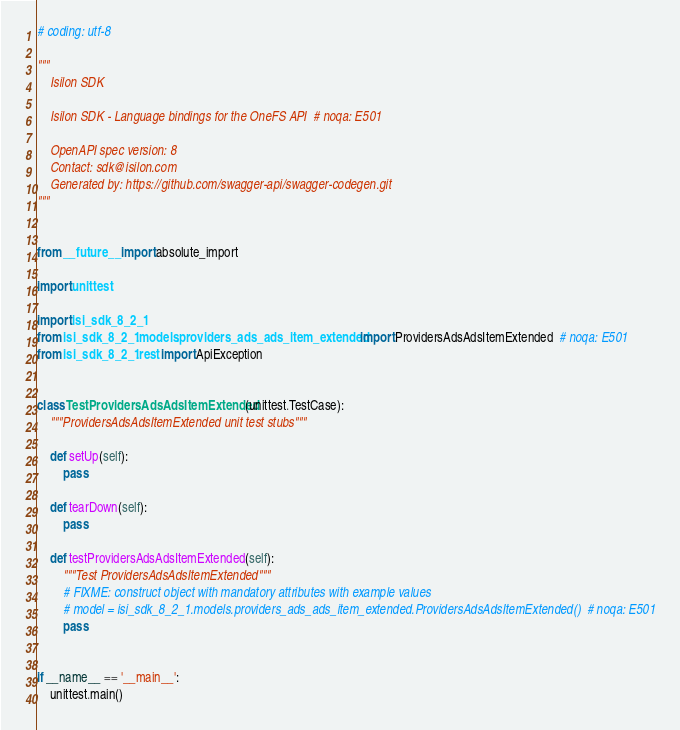<code> <loc_0><loc_0><loc_500><loc_500><_Python_># coding: utf-8

"""
    Isilon SDK

    Isilon SDK - Language bindings for the OneFS API  # noqa: E501

    OpenAPI spec version: 8
    Contact: sdk@isilon.com
    Generated by: https://github.com/swagger-api/swagger-codegen.git
"""


from __future__ import absolute_import

import unittest

import isi_sdk_8_2_1
from isi_sdk_8_2_1.models.providers_ads_ads_item_extended import ProvidersAdsAdsItemExtended  # noqa: E501
from isi_sdk_8_2_1.rest import ApiException


class TestProvidersAdsAdsItemExtended(unittest.TestCase):
    """ProvidersAdsAdsItemExtended unit test stubs"""

    def setUp(self):
        pass

    def tearDown(self):
        pass

    def testProvidersAdsAdsItemExtended(self):
        """Test ProvidersAdsAdsItemExtended"""
        # FIXME: construct object with mandatory attributes with example values
        # model = isi_sdk_8_2_1.models.providers_ads_ads_item_extended.ProvidersAdsAdsItemExtended()  # noqa: E501
        pass


if __name__ == '__main__':
    unittest.main()
</code> 